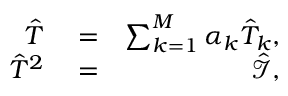Convert formula to latex. <formula><loc_0><loc_0><loc_500><loc_500>\begin{array} { r l r } { \hat { T } } & = } & { \sum _ { k = 1 } ^ { M } \alpha _ { k } \hat { T } _ { k } , } \\ { \hat { T } ^ { 2 } } & = } & { \mathcal { \hat { I } } , } \end{array}</formula> 